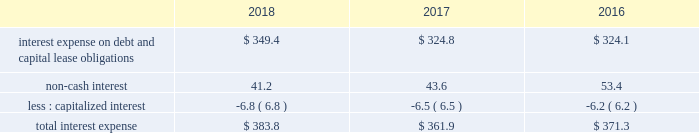Gain on business divestitures and impairments , net we strive to have a number one or number two market position in each of the markets we serve , or have a clear path on how we will achieve a leading market position over time .
Where we cannot establish a leading market position , or where operations are not generating acceptable returns , we may decide to divest certain assets and reallocate resources to other markets .
Asset or business divestitures could result in gains , losses or asset impairment charges that may be material to our results of operations in a given period .
During 2018 , we recorded a net gain on business divestitures , net of asset impairments of $ 44.9 million .
During 2017 , we recorded a net gain on business divestitures , net of asset impairments of $ 27.1 million .
We also recorded a gain on business divestitures of $ 6.8 million due to the transfer of ownership of the landfill gas collection and control system and the remaining post-closure and environmental liabilities associated with one of our divested landfills .
During 2016 , we recorded a charge to earnings of $ 4.6 million primarily related to environmental costs associated with one of our divested landfills .
During 2016 , we also recorded a net gain related to a business divestiture of $ 4.7 million .
Restructuring charges in january 2018 , we eliminated certain positions following the consolidation of select back-office functions , including but not limited to the integration of our national accounts support functions into our existing corporate support functions .
These changes include a reduction in administrative staffing and the closure of certain office locations .
During 2018 , we incurred restructuring charges of $ 26.4 million that primarily consisted of severance and other employee termination benefits , the closure of offices with non-cancelable lease agreements , and the redesign of our back-office functions and upgrades to certain of our software systems .
We paid $ 24.7 million during 2018 related to these restructuring efforts .
In january 2016 , we realigned our field support functions by combining our three regions into two field groups , consolidating our areas and streamlining select operational support roles at our phoenix headquarters .
Additionally , in the second quarter of 2016 , we began the redesign of our back-office functions as well as the consolidation of over 100 customer service locations into three customer resource centers .
The redesign of our back-office functions and upgrades to certain of our software systems continued into 2018 .
During the years ended december 31 , 2017 and 2016 , we incurred $ 17.6 million and $ 40.7 million of restructuring charges , respectively , that primarily consisted of severance and other employee termination benefits , transition costs , relocation benefits , and the closure of offices with lease agreements with non-cancelable terms .
The savings realized from these restructuring efforts have been reinvested in our customer-focused programs and initiatives .
Interest expense the table provides the components of interest expense , including accretion of debt discounts and accretion of discounts primarily associated with environmental and risk insurance liabilities assumed in acquisitions ( in millions of dollars ) : .
Total interest expense for 2018 increased compared to 2017 primarily due to the increase in debt outstanding during the period and higher interest rates on floating rate debt .
Total interest expense for 2017 decreased .
What was the growth in the interest expense on debt and capital lease obligations from 2017 to 2018? 
Rationale: the growth is based on the subtraction of the current from the prior period amount divide by the prior period
Computations: ((349.4 - 324.8) / 324.8)
Answer: 0.07574. 